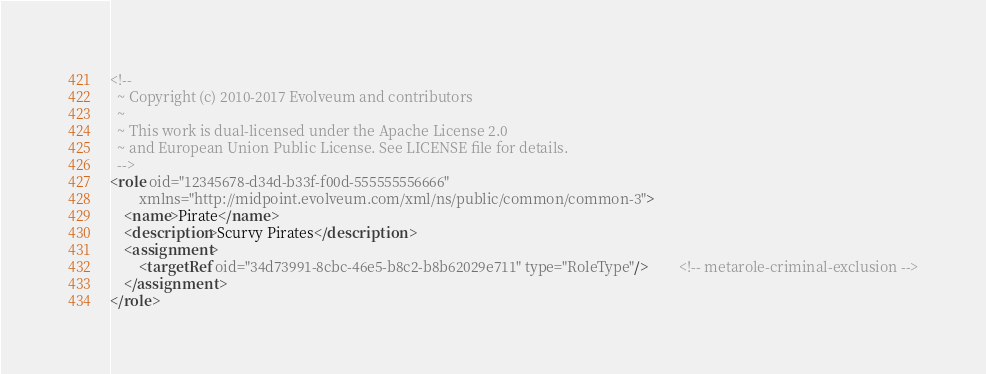Convert code to text. <code><loc_0><loc_0><loc_500><loc_500><_XML_><!--
  ~ Copyright (c) 2010-2017 Evolveum and contributors
  ~
  ~ This work is dual-licensed under the Apache License 2.0
  ~ and European Union Public License. See LICENSE file for details.
  -->
<role oid="12345678-d34d-b33f-f00d-555555556666"
        xmlns="http://midpoint.evolveum.com/xml/ns/public/common/common-3">
    <name>Pirate</name>
    <description>Scurvy Pirates</description>
    <assignment>
        <targetRef oid="34d73991-8cbc-46e5-b8c2-b8b62029e711" type="RoleType"/>         <!-- metarole-criminal-exclusion -->
    </assignment>
</role>
</code> 